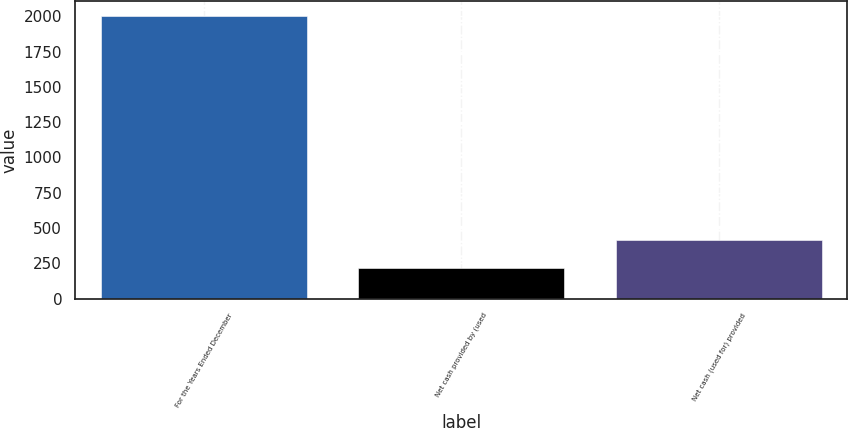Convert chart. <chart><loc_0><loc_0><loc_500><loc_500><bar_chart><fcel>For the Years Ended December<fcel>Net cash provided by (used<fcel>Net cash (used for) provided<nl><fcel>2005<fcel>216.7<fcel>415.4<nl></chart> 